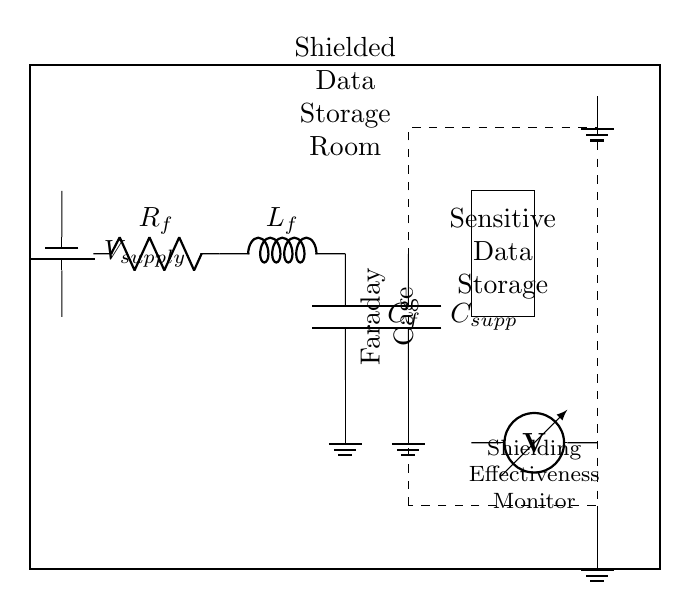What is the main function of the components in this circuit? The main function is to shield sensitive data storage from electromagnetic interference. The circuit comprises an EMI filter and a Faraday cage, which work together to prevent external noise from affecting the data.
Answer: Shielding What type of circuit is represented? This circuit represents a shielding and EMI suppression circuit designed specifically for data storage security. The components are tailored to minimize interference, showcasing a targeted solution for sensitive environments.
Answer: Shielding and EMI suppression How many grounding points are present in the diagram? There are three grounding points shown in the circuit diagram: one for the EMI filter grounding and two additional for the sensitive equipment and Faraday cage.
Answer: Three What is the value of the supply voltage? The supply voltage is denoted as V supply, which suggests that it can be a variable voltage meant for powering the components, but it is not specified numerically in the diagram.
Answer: V supply What component is used to monitor shielding effectiveness? A voltmeter is used to monitor the shielding effectiveness, as indicated in the diagram where it is connected to the sensitive equipment.
Answer: Voltmeter What type of component is C f? C f is a capacitor, which provides filtering to reduce interference in the circuit, thus playing a critical role in the EMI suppression strategy.
Answer: Capacitor Which component creates the Faraday cage effect in the diagram? The dashed rectangle representing the Faraday cage illustrates the component that creates this effect, effectively inhibiting electromagnetic fields.
Answer: Faraday cage 